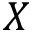<formula> <loc_0><loc_0><loc_500><loc_500>X</formula> 